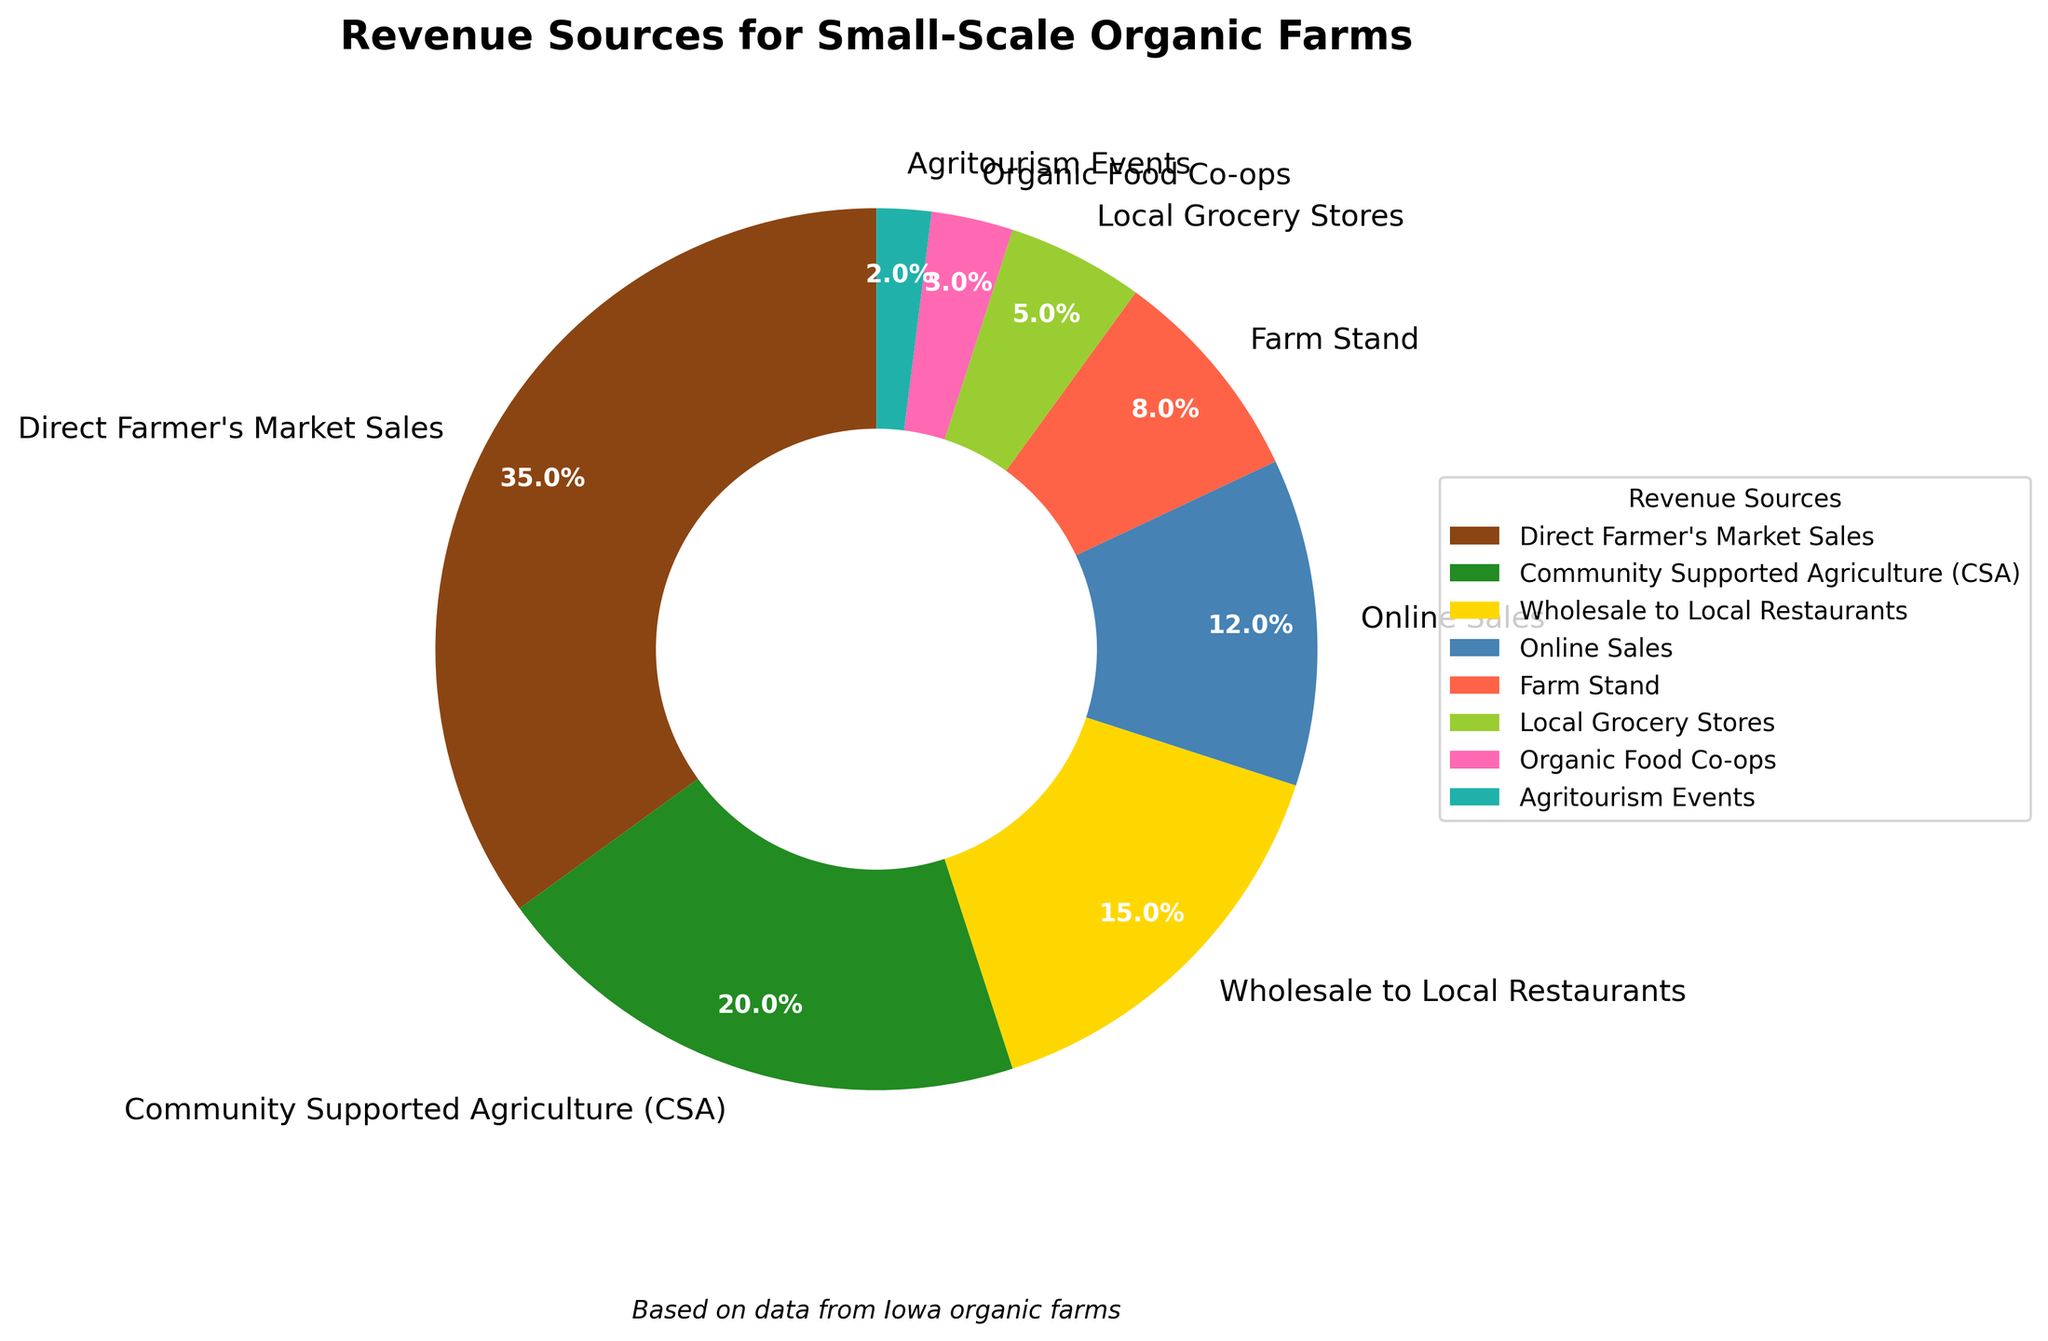Which revenue source contributes the largest percentage to the total revenue? Identify the revenue source which has the largest percentage on the pie chart, which is clearly labeled.
Answer: Direct Farmer's Market Sales What is the combined percentage of revenue from Wholesale to Local Restaurants and Local Grocery Stores? Add the percentages for Wholesale to Local Restaurants (15%) and Local Grocery Stores (5%). 15% + 5% = 20%
Answer: 20% Which revenue source has a smaller percentage: Online Sales or Farm Stand? Compare the percentages for Online Sales (12%) and Farm Stand (8%). 8% is smaller than 12%.
Answer: Farm Stand What is the total percentage contribution of Agritourism Events, Organic Food Co-ops, and Local Grocery Stores? Add the percentages for Agritourism Events (2%), Organic Food Co-ops (3%), and Local Grocery Stores (5%). 2% + 3% + 5% = 10%
Answer: 10% What color represents Community Supported Agriculture (CSA) in the pie chart? Identify the segment labeled Community Supported Agriculture (CSA) in the pie chart and note its color.
Answer: Green How much is the difference in percentage between the highest and lowest revenue sources? Subtract the percentage of the smallest contributor, Agritourism Events (2%), from the largest contributor, Direct Farmer's Market Sales (35%). 35% - 2% = 33%
Answer: 33% What is the average percentage contribution of Direct Farmer's Market Sales, Community Supported Agriculture (CSA), and Online Sales? Calculate the sum of the percentages for Direct Farmer's Market Sales (35%), Community Supported Agriculture (CSA) (20%), and Online Sales (12%) and divide by 3. (35% + 20% + 12%) / 3 = 22.33%
Answer: 22.33% What revenue source lies between Farm Stand and Online Sales in terms of percentage contribution? Identify the revenue sources and their contributions and see which one falls in between Farm Stand (8%) and Online Sales (12%).
Answer: Farm Stand Which two sources together make up exactly 50% of the total revenue? Combine the percentages of multiple sources to see which pairs sum up to 50%. Direct Farmer's Market Sales (35%) and Community Supported Agriculture (20%) do. 35% + 20% = 50%
Answer: Direct Farmer's Market Sales and Community Supported Agriculture (CSA) 